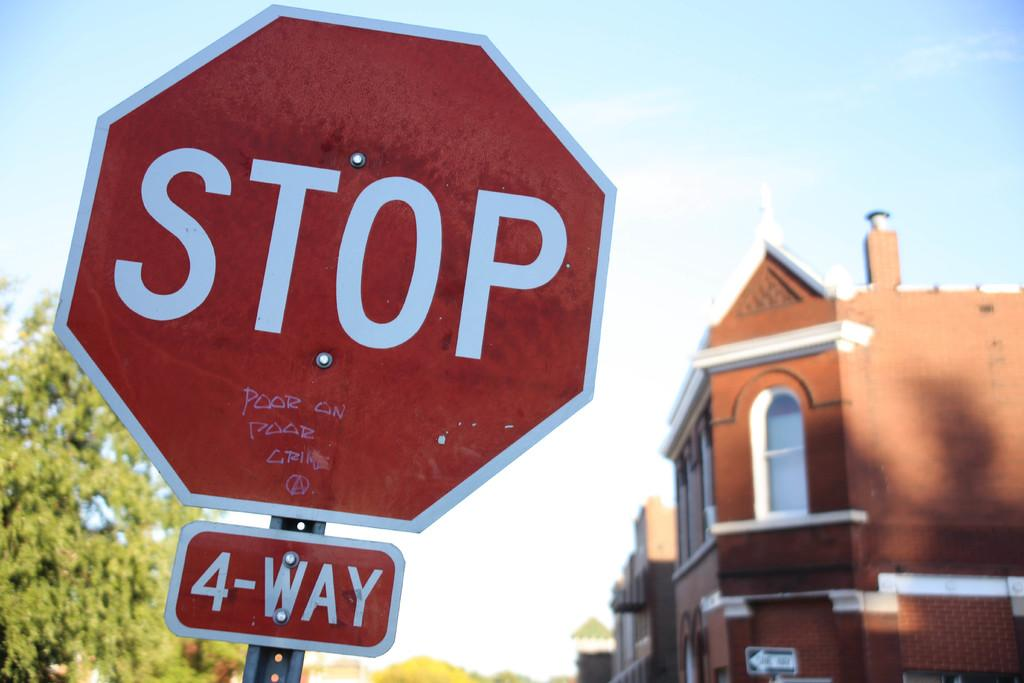Provide a one-sentence caption for the provided image. A four way stop sign with graffiti on the bottom of the sign saying "poor on poor crime". 